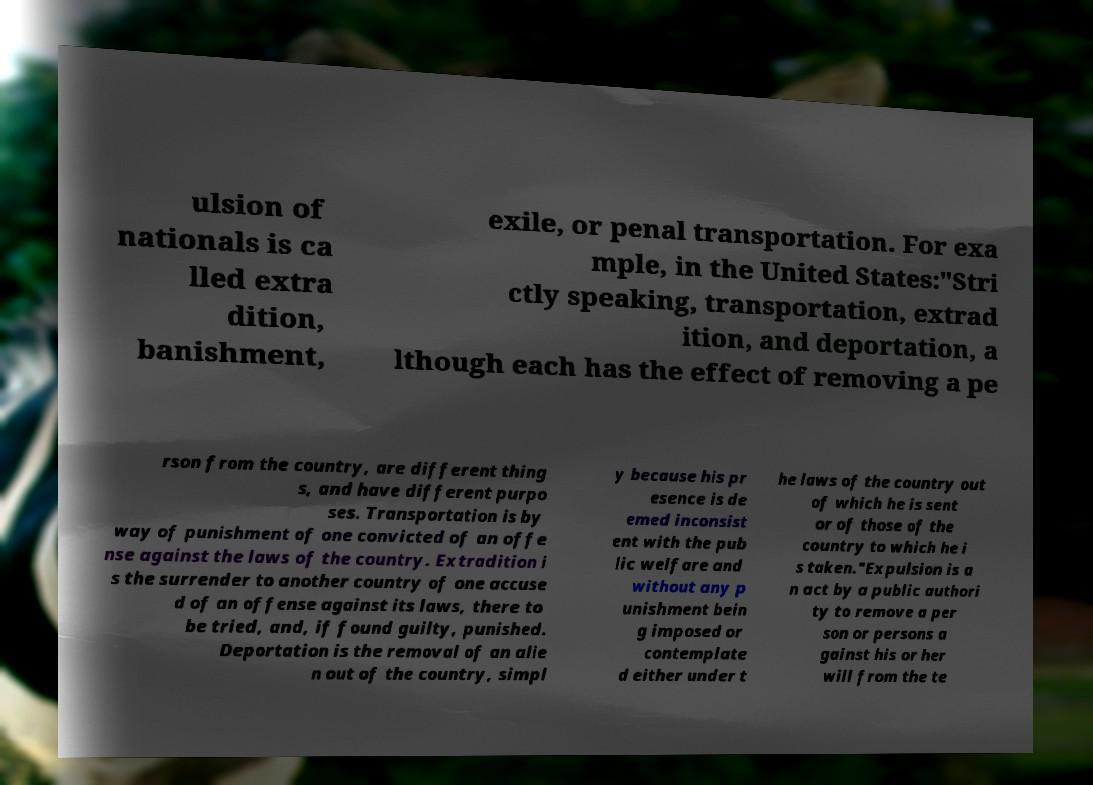Please identify and transcribe the text found in this image. ulsion of nationals is ca lled extra dition, banishment, exile, or penal transportation. For exa mple, in the United States:"Stri ctly speaking, transportation, extrad ition, and deportation, a lthough each has the effect of removing a pe rson from the country, are different thing s, and have different purpo ses. Transportation is by way of punishment of one convicted of an offe nse against the laws of the country. Extradition i s the surrender to another country of one accuse d of an offense against its laws, there to be tried, and, if found guilty, punished. Deportation is the removal of an alie n out of the country, simpl y because his pr esence is de emed inconsist ent with the pub lic welfare and without any p unishment bein g imposed or contemplate d either under t he laws of the country out of which he is sent or of those of the country to which he i s taken."Expulsion is a n act by a public authori ty to remove a per son or persons a gainst his or her will from the te 